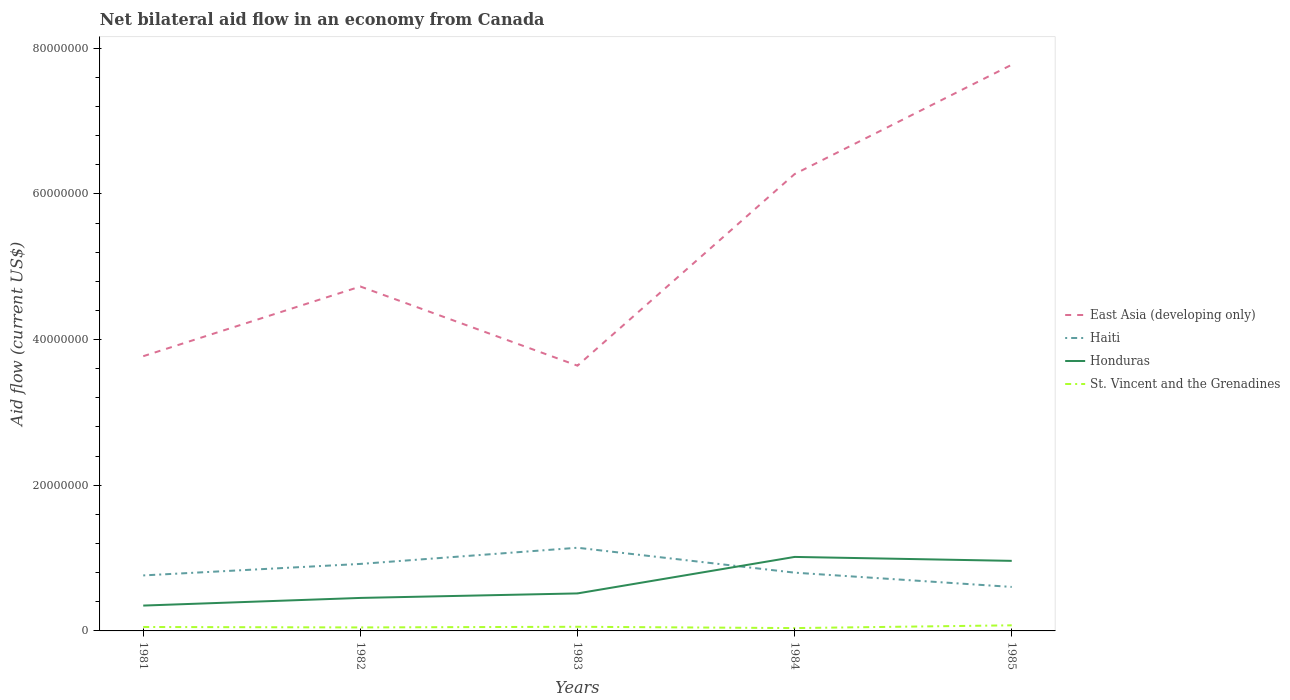How many different coloured lines are there?
Provide a succinct answer. 4. Does the line corresponding to Honduras intersect with the line corresponding to St. Vincent and the Grenadines?
Provide a succinct answer. No. Across all years, what is the maximum net bilateral aid flow in Haiti?
Offer a terse response. 6.04e+06. What is the total net bilateral aid flow in East Asia (developing only) in the graph?
Your response must be concise. -2.50e+07. What is the difference between the highest and the second highest net bilateral aid flow in East Asia (developing only)?
Provide a short and direct response. 4.13e+07. What is the difference between the highest and the lowest net bilateral aid flow in Honduras?
Provide a succinct answer. 2. Is the net bilateral aid flow in Honduras strictly greater than the net bilateral aid flow in St. Vincent and the Grenadines over the years?
Provide a succinct answer. No. How many lines are there?
Your response must be concise. 4. What is the difference between two consecutive major ticks on the Y-axis?
Keep it short and to the point. 2.00e+07. Are the values on the major ticks of Y-axis written in scientific E-notation?
Make the answer very short. No. Where does the legend appear in the graph?
Offer a very short reply. Center right. How are the legend labels stacked?
Offer a very short reply. Vertical. What is the title of the graph?
Your answer should be very brief. Net bilateral aid flow in an economy from Canada. Does "Canada" appear as one of the legend labels in the graph?
Provide a succinct answer. No. What is the label or title of the Y-axis?
Offer a terse response. Aid flow (current US$). What is the Aid flow (current US$) of East Asia (developing only) in 1981?
Provide a short and direct response. 3.77e+07. What is the Aid flow (current US$) in Haiti in 1981?
Give a very brief answer. 7.62e+06. What is the Aid flow (current US$) in Honduras in 1981?
Ensure brevity in your answer.  3.48e+06. What is the Aid flow (current US$) in St. Vincent and the Grenadines in 1981?
Keep it short and to the point. 5.40e+05. What is the Aid flow (current US$) of East Asia (developing only) in 1982?
Give a very brief answer. 4.73e+07. What is the Aid flow (current US$) in Haiti in 1982?
Your answer should be very brief. 9.20e+06. What is the Aid flow (current US$) of Honduras in 1982?
Offer a terse response. 4.53e+06. What is the Aid flow (current US$) in East Asia (developing only) in 1983?
Provide a succinct answer. 3.64e+07. What is the Aid flow (current US$) in Haiti in 1983?
Your answer should be very brief. 1.14e+07. What is the Aid flow (current US$) in Honduras in 1983?
Offer a terse response. 5.15e+06. What is the Aid flow (current US$) in St. Vincent and the Grenadines in 1983?
Your answer should be compact. 5.70e+05. What is the Aid flow (current US$) in East Asia (developing only) in 1984?
Keep it short and to the point. 6.27e+07. What is the Aid flow (current US$) of Honduras in 1984?
Give a very brief answer. 1.02e+07. What is the Aid flow (current US$) of St. Vincent and the Grenadines in 1984?
Provide a short and direct response. 3.90e+05. What is the Aid flow (current US$) in East Asia (developing only) in 1985?
Your answer should be compact. 7.77e+07. What is the Aid flow (current US$) in Haiti in 1985?
Keep it short and to the point. 6.04e+06. What is the Aid flow (current US$) in Honduras in 1985?
Keep it short and to the point. 9.62e+06. What is the Aid flow (current US$) of St. Vincent and the Grenadines in 1985?
Your response must be concise. 7.70e+05. Across all years, what is the maximum Aid flow (current US$) of East Asia (developing only)?
Give a very brief answer. 7.77e+07. Across all years, what is the maximum Aid flow (current US$) of Haiti?
Make the answer very short. 1.14e+07. Across all years, what is the maximum Aid flow (current US$) of Honduras?
Your answer should be compact. 1.02e+07. Across all years, what is the maximum Aid flow (current US$) in St. Vincent and the Grenadines?
Provide a succinct answer. 7.70e+05. Across all years, what is the minimum Aid flow (current US$) in East Asia (developing only)?
Your answer should be compact. 3.64e+07. Across all years, what is the minimum Aid flow (current US$) in Haiti?
Your response must be concise. 6.04e+06. Across all years, what is the minimum Aid flow (current US$) of Honduras?
Make the answer very short. 3.48e+06. What is the total Aid flow (current US$) in East Asia (developing only) in the graph?
Provide a succinct answer. 2.62e+08. What is the total Aid flow (current US$) in Haiti in the graph?
Ensure brevity in your answer.  4.23e+07. What is the total Aid flow (current US$) in Honduras in the graph?
Your answer should be compact. 3.29e+07. What is the total Aid flow (current US$) of St. Vincent and the Grenadines in the graph?
Ensure brevity in your answer.  2.75e+06. What is the difference between the Aid flow (current US$) in East Asia (developing only) in 1981 and that in 1982?
Your response must be concise. -9.57e+06. What is the difference between the Aid flow (current US$) in Haiti in 1981 and that in 1982?
Your answer should be very brief. -1.58e+06. What is the difference between the Aid flow (current US$) in Honduras in 1981 and that in 1982?
Your response must be concise. -1.05e+06. What is the difference between the Aid flow (current US$) of East Asia (developing only) in 1981 and that in 1983?
Make the answer very short. 1.30e+06. What is the difference between the Aid flow (current US$) in Haiti in 1981 and that in 1983?
Keep it short and to the point. -3.80e+06. What is the difference between the Aid flow (current US$) in Honduras in 1981 and that in 1983?
Keep it short and to the point. -1.67e+06. What is the difference between the Aid flow (current US$) in East Asia (developing only) in 1981 and that in 1984?
Make the answer very short. -2.50e+07. What is the difference between the Aid flow (current US$) of Haiti in 1981 and that in 1984?
Make the answer very short. -3.80e+05. What is the difference between the Aid flow (current US$) in Honduras in 1981 and that in 1984?
Keep it short and to the point. -6.68e+06. What is the difference between the Aid flow (current US$) in St. Vincent and the Grenadines in 1981 and that in 1984?
Provide a short and direct response. 1.50e+05. What is the difference between the Aid flow (current US$) in East Asia (developing only) in 1981 and that in 1985?
Keep it short and to the point. -4.00e+07. What is the difference between the Aid flow (current US$) of Haiti in 1981 and that in 1985?
Provide a succinct answer. 1.58e+06. What is the difference between the Aid flow (current US$) of Honduras in 1981 and that in 1985?
Give a very brief answer. -6.14e+06. What is the difference between the Aid flow (current US$) of St. Vincent and the Grenadines in 1981 and that in 1985?
Ensure brevity in your answer.  -2.30e+05. What is the difference between the Aid flow (current US$) in East Asia (developing only) in 1982 and that in 1983?
Provide a succinct answer. 1.09e+07. What is the difference between the Aid flow (current US$) of Haiti in 1982 and that in 1983?
Provide a short and direct response. -2.22e+06. What is the difference between the Aid flow (current US$) of Honduras in 1982 and that in 1983?
Ensure brevity in your answer.  -6.20e+05. What is the difference between the Aid flow (current US$) of East Asia (developing only) in 1982 and that in 1984?
Your response must be concise. -1.54e+07. What is the difference between the Aid flow (current US$) of Haiti in 1982 and that in 1984?
Make the answer very short. 1.20e+06. What is the difference between the Aid flow (current US$) in Honduras in 1982 and that in 1984?
Ensure brevity in your answer.  -5.63e+06. What is the difference between the Aid flow (current US$) in East Asia (developing only) in 1982 and that in 1985?
Your answer should be very brief. -3.04e+07. What is the difference between the Aid flow (current US$) of Haiti in 1982 and that in 1985?
Your answer should be compact. 3.16e+06. What is the difference between the Aid flow (current US$) of Honduras in 1982 and that in 1985?
Provide a succinct answer. -5.09e+06. What is the difference between the Aid flow (current US$) of St. Vincent and the Grenadines in 1982 and that in 1985?
Offer a terse response. -2.90e+05. What is the difference between the Aid flow (current US$) of East Asia (developing only) in 1983 and that in 1984?
Keep it short and to the point. -2.63e+07. What is the difference between the Aid flow (current US$) of Haiti in 1983 and that in 1984?
Provide a succinct answer. 3.42e+06. What is the difference between the Aid flow (current US$) in Honduras in 1983 and that in 1984?
Provide a short and direct response. -5.01e+06. What is the difference between the Aid flow (current US$) of East Asia (developing only) in 1983 and that in 1985?
Provide a succinct answer. -4.13e+07. What is the difference between the Aid flow (current US$) in Haiti in 1983 and that in 1985?
Offer a terse response. 5.38e+06. What is the difference between the Aid flow (current US$) of Honduras in 1983 and that in 1985?
Your response must be concise. -4.47e+06. What is the difference between the Aid flow (current US$) in St. Vincent and the Grenadines in 1983 and that in 1985?
Provide a succinct answer. -2.00e+05. What is the difference between the Aid flow (current US$) in East Asia (developing only) in 1984 and that in 1985?
Offer a terse response. -1.50e+07. What is the difference between the Aid flow (current US$) in Haiti in 1984 and that in 1985?
Your answer should be compact. 1.96e+06. What is the difference between the Aid flow (current US$) in Honduras in 1984 and that in 1985?
Keep it short and to the point. 5.40e+05. What is the difference between the Aid flow (current US$) of St. Vincent and the Grenadines in 1984 and that in 1985?
Give a very brief answer. -3.80e+05. What is the difference between the Aid flow (current US$) in East Asia (developing only) in 1981 and the Aid flow (current US$) in Haiti in 1982?
Provide a short and direct response. 2.85e+07. What is the difference between the Aid flow (current US$) of East Asia (developing only) in 1981 and the Aid flow (current US$) of Honduras in 1982?
Your answer should be very brief. 3.32e+07. What is the difference between the Aid flow (current US$) of East Asia (developing only) in 1981 and the Aid flow (current US$) of St. Vincent and the Grenadines in 1982?
Give a very brief answer. 3.72e+07. What is the difference between the Aid flow (current US$) of Haiti in 1981 and the Aid flow (current US$) of Honduras in 1982?
Give a very brief answer. 3.09e+06. What is the difference between the Aid flow (current US$) of Haiti in 1981 and the Aid flow (current US$) of St. Vincent and the Grenadines in 1982?
Offer a terse response. 7.14e+06. What is the difference between the Aid flow (current US$) in East Asia (developing only) in 1981 and the Aid flow (current US$) in Haiti in 1983?
Offer a terse response. 2.63e+07. What is the difference between the Aid flow (current US$) in East Asia (developing only) in 1981 and the Aid flow (current US$) in Honduras in 1983?
Provide a short and direct response. 3.26e+07. What is the difference between the Aid flow (current US$) of East Asia (developing only) in 1981 and the Aid flow (current US$) of St. Vincent and the Grenadines in 1983?
Make the answer very short. 3.72e+07. What is the difference between the Aid flow (current US$) of Haiti in 1981 and the Aid flow (current US$) of Honduras in 1983?
Make the answer very short. 2.47e+06. What is the difference between the Aid flow (current US$) of Haiti in 1981 and the Aid flow (current US$) of St. Vincent and the Grenadines in 1983?
Offer a terse response. 7.05e+06. What is the difference between the Aid flow (current US$) of Honduras in 1981 and the Aid flow (current US$) of St. Vincent and the Grenadines in 1983?
Your answer should be very brief. 2.91e+06. What is the difference between the Aid flow (current US$) in East Asia (developing only) in 1981 and the Aid flow (current US$) in Haiti in 1984?
Ensure brevity in your answer.  2.97e+07. What is the difference between the Aid flow (current US$) of East Asia (developing only) in 1981 and the Aid flow (current US$) of Honduras in 1984?
Your answer should be very brief. 2.76e+07. What is the difference between the Aid flow (current US$) of East Asia (developing only) in 1981 and the Aid flow (current US$) of St. Vincent and the Grenadines in 1984?
Provide a short and direct response. 3.73e+07. What is the difference between the Aid flow (current US$) in Haiti in 1981 and the Aid flow (current US$) in Honduras in 1984?
Your answer should be compact. -2.54e+06. What is the difference between the Aid flow (current US$) in Haiti in 1981 and the Aid flow (current US$) in St. Vincent and the Grenadines in 1984?
Provide a succinct answer. 7.23e+06. What is the difference between the Aid flow (current US$) in Honduras in 1981 and the Aid flow (current US$) in St. Vincent and the Grenadines in 1984?
Keep it short and to the point. 3.09e+06. What is the difference between the Aid flow (current US$) of East Asia (developing only) in 1981 and the Aid flow (current US$) of Haiti in 1985?
Provide a short and direct response. 3.17e+07. What is the difference between the Aid flow (current US$) in East Asia (developing only) in 1981 and the Aid flow (current US$) in Honduras in 1985?
Offer a very short reply. 2.81e+07. What is the difference between the Aid flow (current US$) in East Asia (developing only) in 1981 and the Aid flow (current US$) in St. Vincent and the Grenadines in 1985?
Your answer should be very brief. 3.70e+07. What is the difference between the Aid flow (current US$) in Haiti in 1981 and the Aid flow (current US$) in St. Vincent and the Grenadines in 1985?
Provide a succinct answer. 6.85e+06. What is the difference between the Aid flow (current US$) of Honduras in 1981 and the Aid flow (current US$) of St. Vincent and the Grenadines in 1985?
Your answer should be compact. 2.71e+06. What is the difference between the Aid flow (current US$) in East Asia (developing only) in 1982 and the Aid flow (current US$) in Haiti in 1983?
Offer a very short reply. 3.59e+07. What is the difference between the Aid flow (current US$) in East Asia (developing only) in 1982 and the Aid flow (current US$) in Honduras in 1983?
Provide a succinct answer. 4.21e+07. What is the difference between the Aid flow (current US$) of East Asia (developing only) in 1982 and the Aid flow (current US$) of St. Vincent and the Grenadines in 1983?
Keep it short and to the point. 4.67e+07. What is the difference between the Aid flow (current US$) of Haiti in 1982 and the Aid flow (current US$) of Honduras in 1983?
Provide a succinct answer. 4.05e+06. What is the difference between the Aid flow (current US$) in Haiti in 1982 and the Aid flow (current US$) in St. Vincent and the Grenadines in 1983?
Your answer should be very brief. 8.63e+06. What is the difference between the Aid flow (current US$) of Honduras in 1982 and the Aid flow (current US$) of St. Vincent and the Grenadines in 1983?
Provide a succinct answer. 3.96e+06. What is the difference between the Aid flow (current US$) in East Asia (developing only) in 1982 and the Aid flow (current US$) in Haiti in 1984?
Give a very brief answer. 3.93e+07. What is the difference between the Aid flow (current US$) in East Asia (developing only) in 1982 and the Aid flow (current US$) in Honduras in 1984?
Your answer should be compact. 3.71e+07. What is the difference between the Aid flow (current US$) in East Asia (developing only) in 1982 and the Aid flow (current US$) in St. Vincent and the Grenadines in 1984?
Give a very brief answer. 4.69e+07. What is the difference between the Aid flow (current US$) of Haiti in 1982 and the Aid flow (current US$) of Honduras in 1984?
Provide a short and direct response. -9.60e+05. What is the difference between the Aid flow (current US$) of Haiti in 1982 and the Aid flow (current US$) of St. Vincent and the Grenadines in 1984?
Your answer should be very brief. 8.81e+06. What is the difference between the Aid flow (current US$) of Honduras in 1982 and the Aid flow (current US$) of St. Vincent and the Grenadines in 1984?
Ensure brevity in your answer.  4.14e+06. What is the difference between the Aid flow (current US$) in East Asia (developing only) in 1982 and the Aid flow (current US$) in Haiti in 1985?
Your answer should be compact. 4.12e+07. What is the difference between the Aid flow (current US$) in East Asia (developing only) in 1982 and the Aid flow (current US$) in Honduras in 1985?
Make the answer very short. 3.77e+07. What is the difference between the Aid flow (current US$) of East Asia (developing only) in 1982 and the Aid flow (current US$) of St. Vincent and the Grenadines in 1985?
Provide a succinct answer. 4.65e+07. What is the difference between the Aid flow (current US$) in Haiti in 1982 and the Aid flow (current US$) in Honduras in 1985?
Provide a succinct answer. -4.20e+05. What is the difference between the Aid flow (current US$) in Haiti in 1982 and the Aid flow (current US$) in St. Vincent and the Grenadines in 1985?
Your answer should be compact. 8.43e+06. What is the difference between the Aid flow (current US$) of Honduras in 1982 and the Aid flow (current US$) of St. Vincent and the Grenadines in 1985?
Provide a short and direct response. 3.76e+06. What is the difference between the Aid flow (current US$) of East Asia (developing only) in 1983 and the Aid flow (current US$) of Haiti in 1984?
Provide a succinct answer. 2.84e+07. What is the difference between the Aid flow (current US$) of East Asia (developing only) in 1983 and the Aid flow (current US$) of Honduras in 1984?
Your answer should be very brief. 2.63e+07. What is the difference between the Aid flow (current US$) of East Asia (developing only) in 1983 and the Aid flow (current US$) of St. Vincent and the Grenadines in 1984?
Your answer should be compact. 3.60e+07. What is the difference between the Aid flow (current US$) of Haiti in 1983 and the Aid flow (current US$) of Honduras in 1984?
Provide a short and direct response. 1.26e+06. What is the difference between the Aid flow (current US$) in Haiti in 1983 and the Aid flow (current US$) in St. Vincent and the Grenadines in 1984?
Ensure brevity in your answer.  1.10e+07. What is the difference between the Aid flow (current US$) of Honduras in 1983 and the Aid flow (current US$) of St. Vincent and the Grenadines in 1984?
Give a very brief answer. 4.76e+06. What is the difference between the Aid flow (current US$) of East Asia (developing only) in 1983 and the Aid flow (current US$) of Haiti in 1985?
Give a very brief answer. 3.04e+07. What is the difference between the Aid flow (current US$) of East Asia (developing only) in 1983 and the Aid flow (current US$) of Honduras in 1985?
Make the answer very short. 2.68e+07. What is the difference between the Aid flow (current US$) in East Asia (developing only) in 1983 and the Aid flow (current US$) in St. Vincent and the Grenadines in 1985?
Your response must be concise. 3.56e+07. What is the difference between the Aid flow (current US$) of Haiti in 1983 and the Aid flow (current US$) of Honduras in 1985?
Give a very brief answer. 1.80e+06. What is the difference between the Aid flow (current US$) in Haiti in 1983 and the Aid flow (current US$) in St. Vincent and the Grenadines in 1985?
Give a very brief answer. 1.06e+07. What is the difference between the Aid flow (current US$) in Honduras in 1983 and the Aid flow (current US$) in St. Vincent and the Grenadines in 1985?
Your answer should be very brief. 4.38e+06. What is the difference between the Aid flow (current US$) in East Asia (developing only) in 1984 and the Aid flow (current US$) in Haiti in 1985?
Your answer should be very brief. 5.67e+07. What is the difference between the Aid flow (current US$) of East Asia (developing only) in 1984 and the Aid flow (current US$) of Honduras in 1985?
Your response must be concise. 5.31e+07. What is the difference between the Aid flow (current US$) in East Asia (developing only) in 1984 and the Aid flow (current US$) in St. Vincent and the Grenadines in 1985?
Provide a succinct answer. 6.20e+07. What is the difference between the Aid flow (current US$) of Haiti in 1984 and the Aid flow (current US$) of Honduras in 1985?
Offer a terse response. -1.62e+06. What is the difference between the Aid flow (current US$) in Haiti in 1984 and the Aid flow (current US$) in St. Vincent and the Grenadines in 1985?
Provide a succinct answer. 7.23e+06. What is the difference between the Aid flow (current US$) in Honduras in 1984 and the Aid flow (current US$) in St. Vincent and the Grenadines in 1985?
Keep it short and to the point. 9.39e+06. What is the average Aid flow (current US$) of East Asia (developing only) per year?
Provide a succinct answer. 5.24e+07. What is the average Aid flow (current US$) in Haiti per year?
Offer a very short reply. 8.46e+06. What is the average Aid flow (current US$) in Honduras per year?
Keep it short and to the point. 6.59e+06. What is the average Aid flow (current US$) in St. Vincent and the Grenadines per year?
Keep it short and to the point. 5.50e+05. In the year 1981, what is the difference between the Aid flow (current US$) in East Asia (developing only) and Aid flow (current US$) in Haiti?
Provide a succinct answer. 3.01e+07. In the year 1981, what is the difference between the Aid flow (current US$) of East Asia (developing only) and Aid flow (current US$) of Honduras?
Your answer should be compact. 3.42e+07. In the year 1981, what is the difference between the Aid flow (current US$) of East Asia (developing only) and Aid flow (current US$) of St. Vincent and the Grenadines?
Offer a terse response. 3.72e+07. In the year 1981, what is the difference between the Aid flow (current US$) of Haiti and Aid flow (current US$) of Honduras?
Make the answer very short. 4.14e+06. In the year 1981, what is the difference between the Aid flow (current US$) in Haiti and Aid flow (current US$) in St. Vincent and the Grenadines?
Give a very brief answer. 7.08e+06. In the year 1981, what is the difference between the Aid flow (current US$) of Honduras and Aid flow (current US$) of St. Vincent and the Grenadines?
Offer a very short reply. 2.94e+06. In the year 1982, what is the difference between the Aid flow (current US$) of East Asia (developing only) and Aid flow (current US$) of Haiti?
Offer a very short reply. 3.81e+07. In the year 1982, what is the difference between the Aid flow (current US$) in East Asia (developing only) and Aid flow (current US$) in Honduras?
Your response must be concise. 4.28e+07. In the year 1982, what is the difference between the Aid flow (current US$) of East Asia (developing only) and Aid flow (current US$) of St. Vincent and the Grenadines?
Offer a terse response. 4.68e+07. In the year 1982, what is the difference between the Aid flow (current US$) of Haiti and Aid flow (current US$) of Honduras?
Keep it short and to the point. 4.67e+06. In the year 1982, what is the difference between the Aid flow (current US$) in Haiti and Aid flow (current US$) in St. Vincent and the Grenadines?
Make the answer very short. 8.72e+06. In the year 1982, what is the difference between the Aid flow (current US$) of Honduras and Aid flow (current US$) of St. Vincent and the Grenadines?
Offer a very short reply. 4.05e+06. In the year 1983, what is the difference between the Aid flow (current US$) in East Asia (developing only) and Aid flow (current US$) in Haiti?
Your response must be concise. 2.50e+07. In the year 1983, what is the difference between the Aid flow (current US$) in East Asia (developing only) and Aid flow (current US$) in Honduras?
Offer a terse response. 3.13e+07. In the year 1983, what is the difference between the Aid flow (current US$) in East Asia (developing only) and Aid flow (current US$) in St. Vincent and the Grenadines?
Give a very brief answer. 3.58e+07. In the year 1983, what is the difference between the Aid flow (current US$) of Haiti and Aid flow (current US$) of Honduras?
Your answer should be very brief. 6.27e+06. In the year 1983, what is the difference between the Aid flow (current US$) in Haiti and Aid flow (current US$) in St. Vincent and the Grenadines?
Your response must be concise. 1.08e+07. In the year 1983, what is the difference between the Aid flow (current US$) in Honduras and Aid flow (current US$) in St. Vincent and the Grenadines?
Make the answer very short. 4.58e+06. In the year 1984, what is the difference between the Aid flow (current US$) in East Asia (developing only) and Aid flow (current US$) in Haiti?
Your answer should be compact. 5.47e+07. In the year 1984, what is the difference between the Aid flow (current US$) of East Asia (developing only) and Aid flow (current US$) of Honduras?
Provide a short and direct response. 5.26e+07. In the year 1984, what is the difference between the Aid flow (current US$) of East Asia (developing only) and Aid flow (current US$) of St. Vincent and the Grenadines?
Your answer should be very brief. 6.23e+07. In the year 1984, what is the difference between the Aid flow (current US$) in Haiti and Aid flow (current US$) in Honduras?
Provide a short and direct response. -2.16e+06. In the year 1984, what is the difference between the Aid flow (current US$) in Haiti and Aid flow (current US$) in St. Vincent and the Grenadines?
Ensure brevity in your answer.  7.61e+06. In the year 1984, what is the difference between the Aid flow (current US$) in Honduras and Aid flow (current US$) in St. Vincent and the Grenadines?
Your answer should be very brief. 9.77e+06. In the year 1985, what is the difference between the Aid flow (current US$) of East Asia (developing only) and Aid flow (current US$) of Haiti?
Keep it short and to the point. 7.17e+07. In the year 1985, what is the difference between the Aid flow (current US$) of East Asia (developing only) and Aid flow (current US$) of Honduras?
Offer a terse response. 6.81e+07. In the year 1985, what is the difference between the Aid flow (current US$) of East Asia (developing only) and Aid flow (current US$) of St. Vincent and the Grenadines?
Offer a terse response. 7.70e+07. In the year 1985, what is the difference between the Aid flow (current US$) in Haiti and Aid flow (current US$) in Honduras?
Ensure brevity in your answer.  -3.58e+06. In the year 1985, what is the difference between the Aid flow (current US$) in Haiti and Aid flow (current US$) in St. Vincent and the Grenadines?
Your answer should be compact. 5.27e+06. In the year 1985, what is the difference between the Aid flow (current US$) in Honduras and Aid flow (current US$) in St. Vincent and the Grenadines?
Your answer should be compact. 8.85e+06. What is the ratio of the Aid flow (current US$) in East Asia (developing only) in 1981 to that in 1982?
Make the answer very short. 0.8. What is the ratio of the Aid flow (current US$) of Haiti in 1981 to that in 1982?
Ensure brevity in your answer.  0.83. What is the ratio of the Aid flow (current US$) of Honduras in 1981 to that in 1982?
Offer a terse response. 0.77. What is the ratio of the Aid flow (current US$) in East Asia (developing only) in 1981 to that in 1983?
Your answer should be very brief. 1.04. What is the ratio of the Aid flow (current US$) in Haiti in 1981 to that in 1983?
Offer a terse response. 0.67. What is the ratio of the Aid flow (current US$) of Honduras in 1981 to that in 1983?
Your answer should be compact. 0.68. What is the ratio of the Aid flow (current US$) in St. Vincent and the Grenadines in 1981 to that in 1983?
Ensure brevity in your answer.  0.95. What is the ratio of the Aid flow (current US$) in East Asia (developing only) in 1981 to that in 1984?
Keep it short and to the point. 0.6. What is the ratio of the Aid flow (current US$) of Haiti in 1981 to that in 1984?
Offer a terse response. 0.95. What is the ratio of the Aid flow (current US$) of Honduras in 1981 to that in 1984?
Your answer should be compact. 0.34. What is the ratio of the Aid flow (current US$) in St. Vincent and the Grenadines in 1981 to that in 1984?
Your answer should be compact. 1.38. What is the ratio of the Aid flow (current US$) in East Asia (developing only) in 1981 to that in 1985?
Make the answer very short. 0.49. What is the ratio of the Aid flow (current US$) of Haiti in 1981 to that in 1985?
Make the answer very short. 1.26. What is the ratio of the Aid flow (current US$) of Honduras in 1981 to that in 1985?
Keep it short and to the point. 0.36. What is the ratio of the Aid flow (current US$) in St. Vincent and the Grenadines in 1981 to that in 1985?
Keep it short and to the point. 0.7. What is the ratio of the Aid flow (current US$) of East Asia (developing only) in 1982 to that in 1983?
Keep it short and to the point. 1.3. What is the ratio of the Aid flow (current US$) in Haiti in 1982 to that in 1983?
Offer a terse response. 0.81. What is the ratio of the Aid flow (current US$) in Honduras in 1982 to that in 1983?
Offer a very short reply. 0.88. What is the ratio of the Aid flow (current US$) of St. Vincent and the Grenadines in 1982 to that in 1983?
Your answer should be very brief. 0.84. What is the ratio of the Aid flow (current US$) in East Asia (developing only) in 1982 to that in 1984?
Your answer should be very brief. 0.75. What is the ratio of the Aid flow (current US$) of Haiti in 1982 to that in 1984?
Provide a succinct answer. 1.15. What is the ratio of the Aid flow (current US$) of Honduras in 1982 to that in 1984?
Make the answer very short. 0.45. What is the ratio of the Aid flow (current US$) in St. Vincent and the Grenadines in 1982 to that in 1984?
Your response must be concise. 1.23. What is the ratio of the Aid flow (current US$) of East Asia (developing only) in 1982 to that in 1985?
Provide a short and direct response. 0.61. What is the ratio of the Aid flow (current US$) of Haiti in 1982 to that in 1985?
Your answer should be compact. 1.52. What is the ratio of the Aid flow (current US$) in Honduras in 1982 to that in 1985?
Provide a succinct answer. 0.47. What is the ratio of the Aid flow (current US$) of St. Vincent and the Grenadines in 1982 to that in 1985?
Make the answer very short. 0.62. What is the ratio of the Aid flow (current US$) of East Asia (developing only) in 1983 to that in 1984?
Your answer should be very brief. 0.58. What is the ratio of the Aid flow (current US$) of Haiti in 1983 to that in 1984?
Your response must be concise. 1.43. What is the ratio of the Aid flow (current US$) in Honduras in 1983 to that in 1984?
Your answer should be very brief. 0.51. What is the ratio of the Aid flow (current US$) in St. Vincent and the Grenadines in 1983 to that in 1984?
Your answer should be compact. 1.46. What is the ratio of the Aid flow (current US$) of East Asia (developing only) in 1983 to that in 1985?
Your response must be concise. 0.47. What is the ratio of the Aid flow (current US$) in Haiti in 1983 to that in 1985?
Offer a terse response. 1.89. What is the ratio of the Aid flow (current US$) in Honduras in 1983 to that in 1985?
Offer a very short reply. 0.54. What is the ratio of the Aid flow (current US$) of St. Vincent and the Grenadines in 1983 to that in 1985?
Provide a short and direct response. 0.74. What is the ratio of the Aid flow (current US$) of East Asia (developing only) in 1984 to that in 1985?
Your answer should be compact. 0.81. What is the ratio of the Aid flow (current US$) in Haiti in 1984 to that in 1985?
Your answer should be compact. 1.32. What is the ratio of the Aid flow (current US$) of Honduras in 1984 to that in 1985?
Your response must be concise. 1.06. What is the ratio of the Aid flow (current US$) of St. Vincent and the Grenadines in 1984 to that in 1985?
Your answer should be very brief. 0.51. What is the difference between the highest and the second highest Aid flow (current US$) of East Asia (developing only)?
Provide a short and direct response. 1.50e+07. What is the difference between the highest and the second highest Aid flow (current US$) in Haiti?
Make the answer very short. 2.22e+06. What is the difference between the highest and the second highest Aid flow (current US$) of Honduras?
Your answer should be compact. 5.40e+05. What is the difference between the highest and the lowest Aid flow (current US$) of East Asia (developing only)?
Your answer should be compact. 4.13e+07. What is the difference between the highest and the lowest Aid flow (current US$) of Haiti?
Your answer should be very brief. 5.38e+06. What is the difference between the highest and the lowest Aid flow (current US$) in Honduras?
Offer a terse response. 6.68e+06. What is the difference between the highest and the lowest Aid flow (current US$) in St. Vincent and the Grenadines?
Provide a succinct answer. 3.80e+05. 